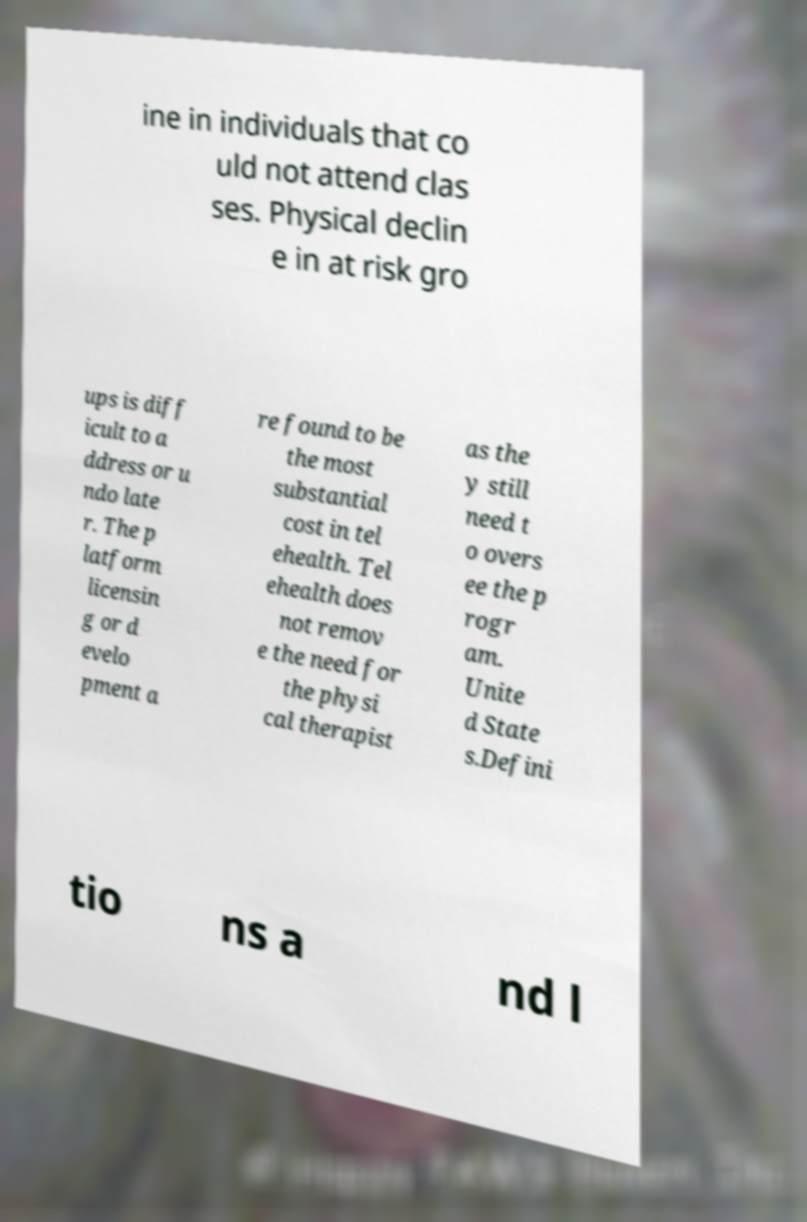What messages or text are displayed in this image? I need them in a readable, typed format. ine in individuals that co uld not attend clas ses. Physical declin e in at risk gro ups is diff icult to a ddress or u ndo late r. The p latform licensin g or d evelo pment a re found to be the most substantial cost in tel ehealth. Tel ehealth does not remov e the need for the physi cal therapist as the y still need t o overs ee the p rogr am. Unite d State s.Defini tio ns a nd l 